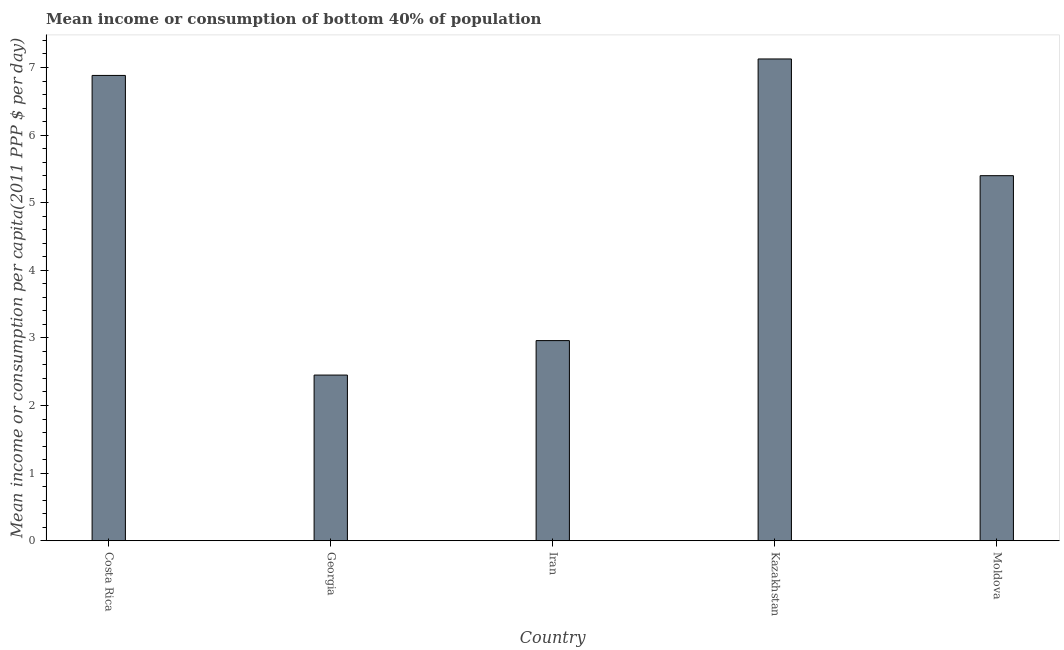Does the graph contain any zero values?
Offer a very short reply. No. What is the title of the graph?
Your answer should be compact. Mean income or consumption of bottom 40% of population. What is the label or title of the X-axis?
Provide a succinct answer. Country. What is the label or title of the Y-axis?
Ensure brevity in your answer.  Mean income or consumption per capita(2011 PPP $ per day). What is the mean income or consumption in Iran?
Your answer should be compact. 2.96. Across all countries, what is the maximum mean income or consumption?
Provide a succinct answer. 7.13. Across all countries, what is the minimum mean income or consumption?
Provide a succinct answer. 2.45. In which country was the mean income or consumption maximum?
Your answer should be compact. Kazakhstan. In which country was the mean income or consumption minimum?
Keep it short and to the point. Georgia. What is the sum of the mean income or consumption?
Provide a short and direct response. 24.82. What is the difference between the mean income or consumption in Iran and Kazakhstan?
Make the answer very short. -4.17. What is the average mean income or consumption per country?
Make the answer very short. 4.96. What is the median mean income or consumption?
Keep it short and to the point. 5.4. What is the ratio of the mean income or consumption in Georgia to that in Kazakhstan?
Give a very brief answer. 0.34. Is the difference between the mean income or consumption in Georgia and Kazakhstan greater than the difference between any two countries?
Give a very brief answer. Yes. What is the difference between the highest and the second highest mean income or consumption?
Make the answer very short. 0.24. What is the difference between the highest and the lowest mean income or consumption?
Offer a very short reply. 4.68. What is the difference between two consecutive major ticks on the Y-axis?
Provide a succinct answer. 1. Are the values on the major ticks of Y-axis written in scientific E-notation?
Provide a succinct answer. No. What is the Mean income or consumption per capita(2011 PPP $ per day) of Costa Rica?
Offer a terse response. 6.88. What is the Mean income or consumption per capita(2011 PPP $ per day) in Georgia?
Your answer should be compact. 2.45. What is the Mean income or consumption per capita(2011 PPP $ per day) in Iran?
Give a very brief answer. 2.96. What is the Mean income or consumption per capita(2011 PPP $ per day) in Kazakhstan?
Provide a short and direct response. 7.13. What is the Mean income or consumption per capita(2011 PPP $ per day) in Moldova?
Provide a short and direct response. 5.4. What is the difference between the Mean income or consumption per capita(2011 PPP $ per day) in Costa Rica and Georgia?
Give a very brief answer. 4.43. What is the difference between the Mean income or consumption per capita(2011 PPP $ per day) in Costa Rica and Iran?
Provide a short and direct response. 3.92. What is the difference between the Mean income or consumption per capita(2011 PPP $ per day) in Costa Rica and Kazakhstan?
Provide a succinct answer. -0.24. What is the difference between the Mean income or consumption per capita(2011 PPP $ per day) in Costa Rica and Moldova?
Ensure brevity in your answer.  1.48. What is the difference between the Mean income or consumption per capita(2011 PPP $ per day) in Georgia and Iran?
Offer a very short reply. -0.51. What is the difference between the Mean income or consumption per capita(2011 PPP $ per day) in Georgia and Kazakhstan?
Give a very brief answer. -4.68. What is the difference between the Mean income or consumption per capita(2011 PPP $ per day) in Georgia and Moldova?
Offer a terse response. -2.95. What is the difference between the Mean income or consumption per capita(2011 PPP $ per day) in Iran and Kazakhstan?
Make the answer very short. -4.17. What is the difference between the Mean income or consumption per capita(2011 PPP $ per day) in Iran and Moldova?
Give a very brief answer. -2.44. What is the difference between the Mean income or consumption per capita(2011 PPP $ per day) in Kazakhstan and Moldova?
Your response must be concise. 1.73. What is the ratio of the Mean income or consumption per capita(2011 PPP $ per day) in Costa Rica to that in Georgia?
Provide a short and direct response. 2.81. What is the ratio of the Mean income or consumption per capita(2011 PPP $ per day) in Costa Rica to that in Iran?
Make the answer very short. 2.33. What is the ratio of the Mean income or consumption per capita(2011 PPP $ per day) in Costa Rica to that in Kazakhstan?
Give a very brief answer. 0.97. What is the ratio of the Mean income or consumption per capita(2011 PPP $ per day) in Costa Rica to that in Moldova?
Offer a terse response. 1.27. What is the ratio of the Mean income or consumption per capita(2011 PPP $ per day) in Georgia to that in Iran?
Make the answer very short. 0.83. What is the ratio of the Mean income or consumption per capita(2011 PPP $ per day) in Georgia to that in Kazakhstan?
Offer a very short reply. 0.34. What is the ratio of the Mean income or consumption per capita(2011 PPP $ per day) in Georgia to that in Moldova?
Your response must be concise. 0.45. What is the ratio of the Mean income or consumption per capita(2011 PPP $ per day) in Iran to that in Kazakhstan?
Make the answer very short. 0.41. What is the ratio of the Mean income or consumption per capita(2011 PPP $ per day) in Iran to that in Moldova?
Make the answer very short. 0.55. What is the ratio of the Mean income or consumption per capita(2011 PPP $ per day) in Kazakhstan to that in Moldova?
Keep it short and to the point. 1.32. 